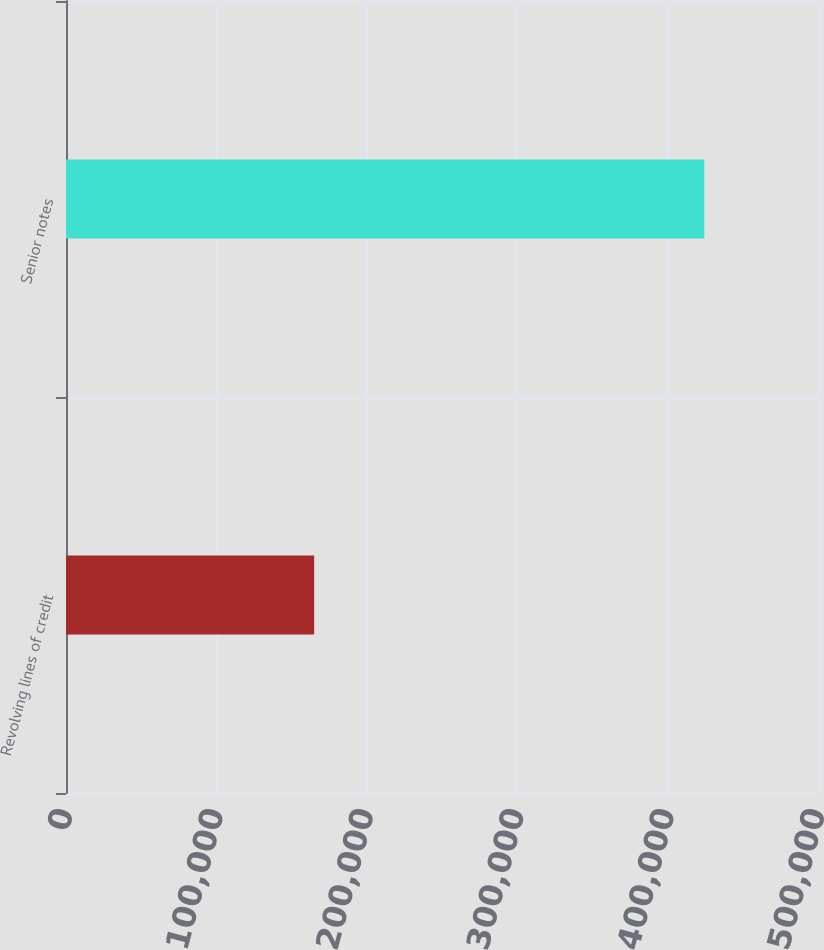<chart> <loc_0><loc_0><loc_500><loc_500><bar_chart><fcel>Revolving lines of credit<fcel>Senior notes<nl><fcel>165000<fcel>424399<nl></chart> 